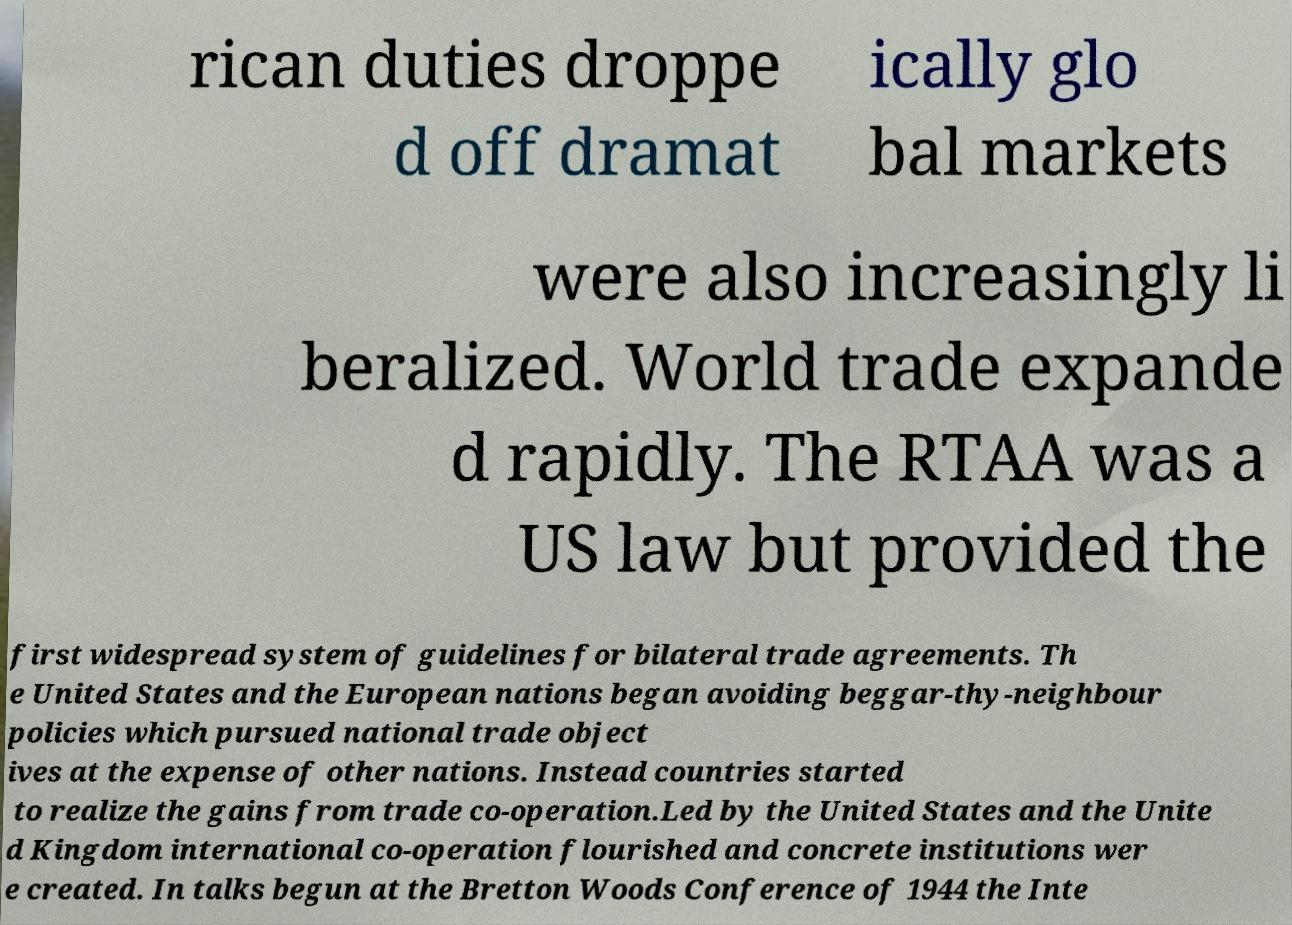Can you accurately transcribe the text from the provided image for me? rican duties droppe d off dramat ically glo bal markets were also increasingly li beralized. World trade expande d rapidly. The RTAA was a US law but provided the first widespread system of guidelines for bilateral trade agreements. Th e United States and the European nations began avoiding beggar-thy-neighbour policies which pursued national trade object ives at the expense of other nations. Instead countries started to realize the gains from trade co-operation.Led by the United States and the Unite d Kingdom international co-operation flourished and concrete institutions wer e created. In talks begun at the Bretton Woods Conference of 1944 the Inte 